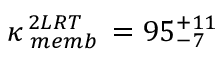Convert formula to latex. <formula><loc_0><loc_0><loc_500><loc_500>\kappa _ { \, m e m b } ^ { \, 2 L R T } \, = 9 5 _ { - 7 } ^ { + 1 1 }</formula> 